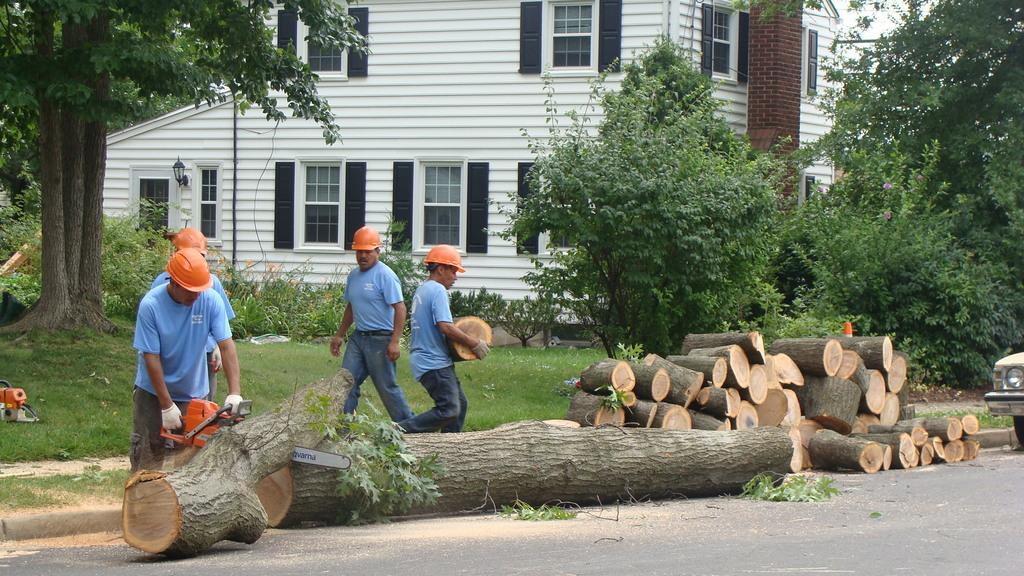Could you give a brief overview of what you see in this image? In this image, we can see four people. Few are holding some objects. Here a person is holding a machine. At the bottom, there is a road, wooden lobbies. Here we can see plants, grass, trees. Background there is a building, wall, glass windows. Here we can see pole and light. Right side of the image, we can see vehicle headlight and tyre. 